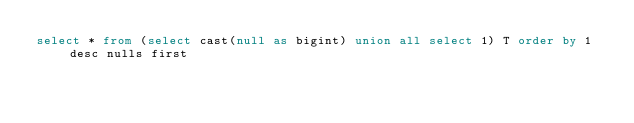Convert code to text. <code><loc_0><loc_0><loc_500><loc_500><_SQL_>select * from (select cast(null as bigint) union all select 1) T order by 1 desc nulls first
</code> 